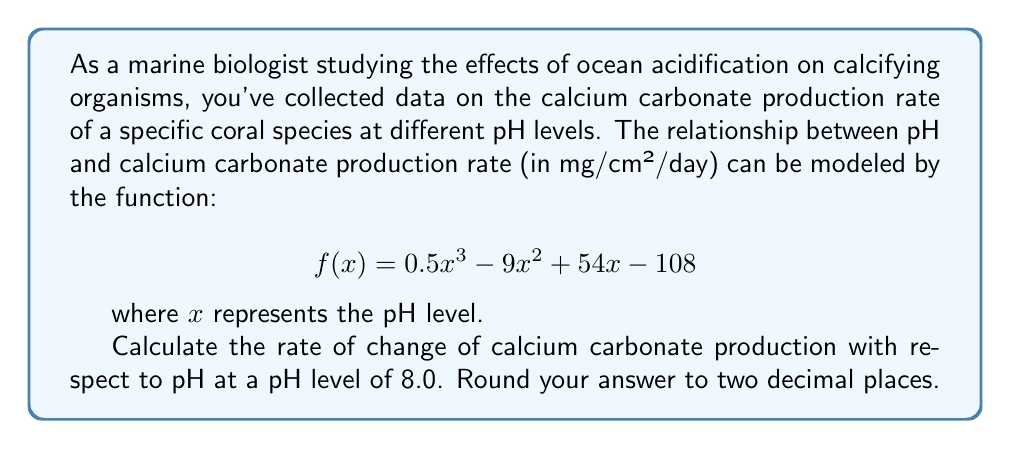Give your solution to this math problem. To solve this problem, we need to follow these steps:

1) The rate of change of calcium carbonate production with respect to pH is given by the derivative of the function $f(x)$.

2) Let's find the derivative of $f(x)$:
   $$f(x) = 0.5x^3 - 9x^2 + 54x - 108$$
   $$f'(x) = 1.5x^2 - 18x + 54$$

3) Now, we need to evaluate $f'(x)$ at $x = 8.0$:
   $$f'(8.0) = 1.5(8.0)^2 - 18(8.0) + 54$$

4) Let's calculate step by step:
   $$f'(8.0) = 1.5(64) - 18(8) + 54$$
   $$f'(8.0) = 96 - 144 + 54$$
   $$f'(8.0) = 6$$

5) The question asks to round to two decimal places, so our final answer is 6.00 mg/cm²/day/pH unit.

This result indicates that at a pH of 8.0, for a small increase in pH, the calcium carbonate production rate is increasing at a rate of 6.00 mg/cm²/day per unit increase in pH.
Answer: 6.00 mg/cm²/day/pH unit 